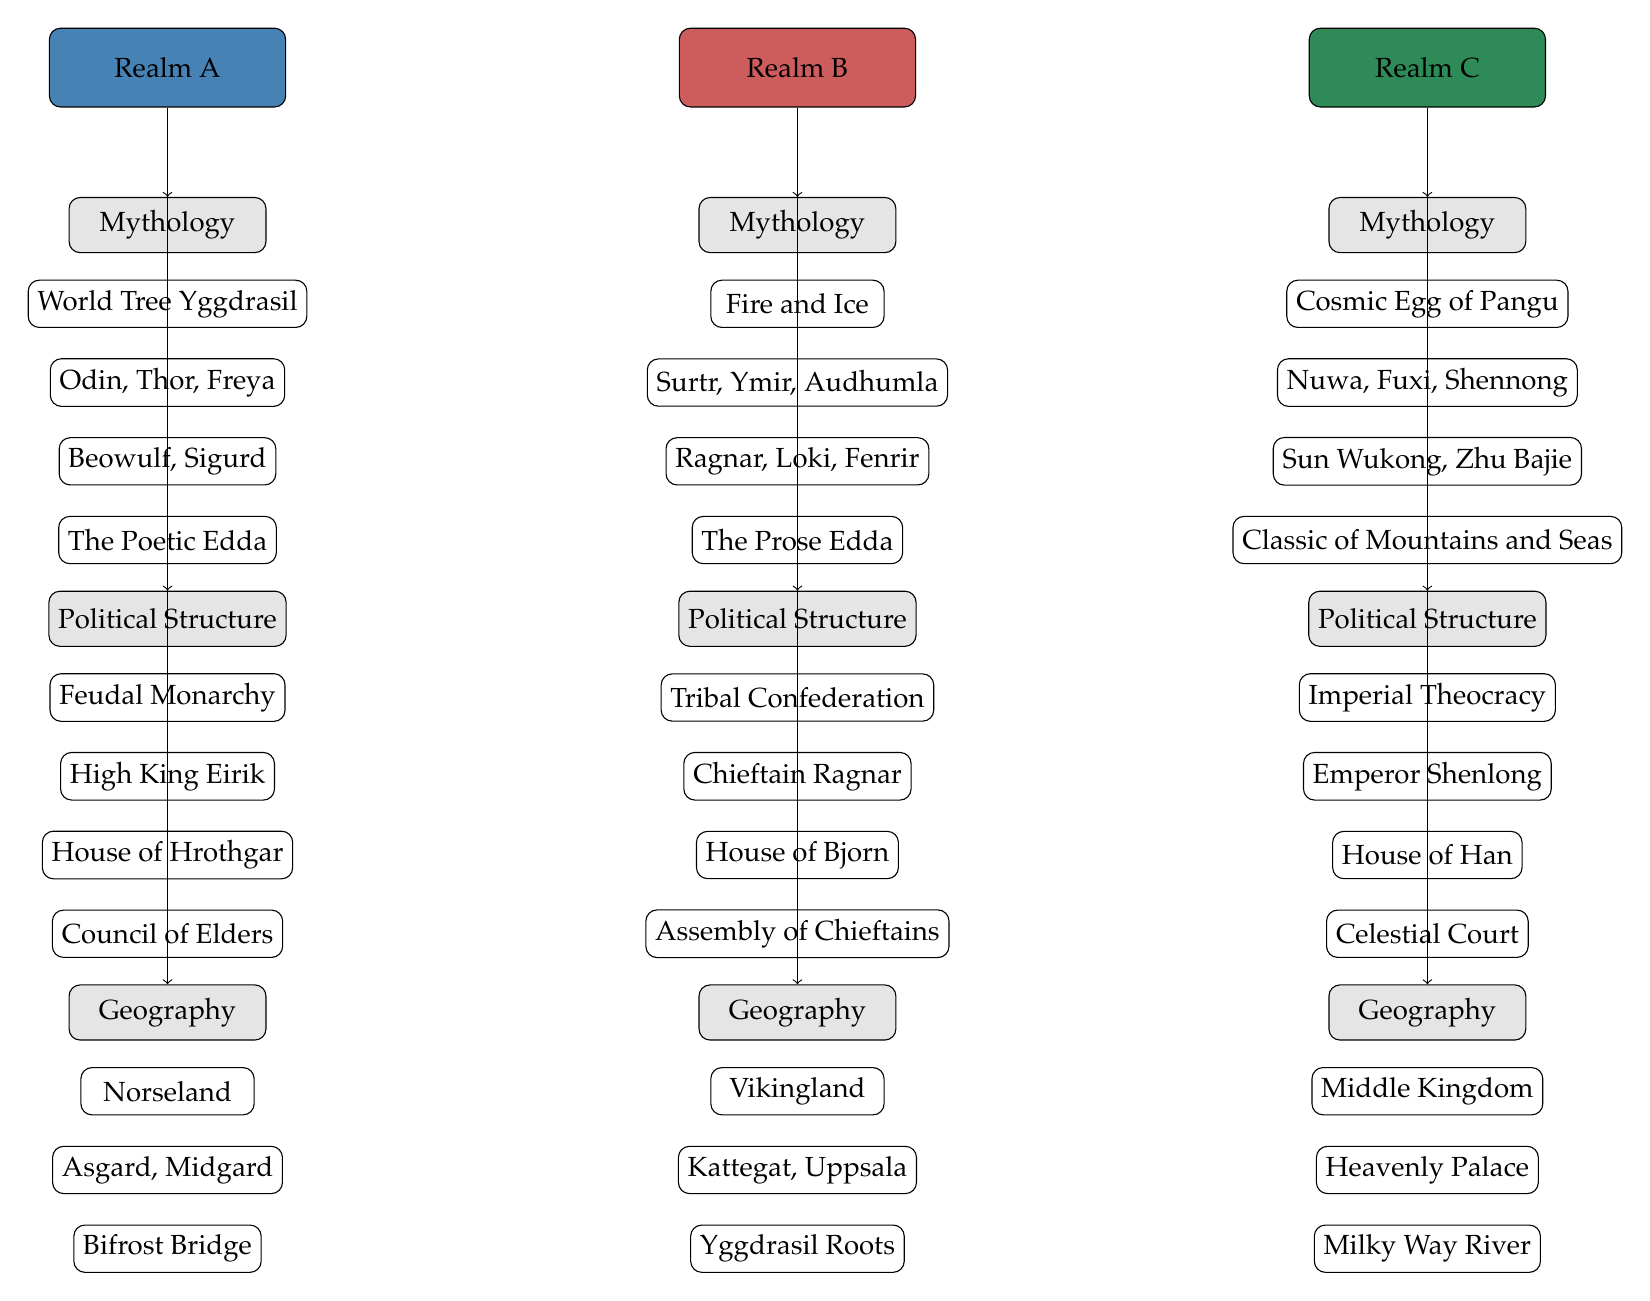What is the primary political structure in Realm A? Realm A's primary political structure is labeled directly under "Political Structure," which states "Feudal Monarchy."
Answer: Feudal Monarchy Which deity is associated with Realm C? The deities associated with Realm C are listed under its "Mythology" category, specifically mentioning "Nuwa, Fuxi, Shennong."
Answer: Nuwa, Fuxi, Shennong How many distinct realms are depicted in this diagram? The diagram presents three distinct realms, namely Realm A, Realm B, and Realm C, as identified at the top of the diagram.
Answer: 3 What significant geographical feature is found in Realm A? Under the "Geography" section for Realm A, the feature listed is "Bifrost Bridge," indicating its significance in this fantasy realm.
Answer: Bifrost Bridge Who rules in Realm B? The ruler of Realm B is identified under the "Political Structure" section, listed as "Chieftain Ragnar."
Answer: Chieftain Ragnar What is the common theme among all realms in the "Mythology" category? Each realm's mythology includes a unique creation myth, showing a variety of foundational stories: Yggdrasil for Realm A, Fire and Ice for Realm B, and the Cosmic Egg for Realm C. The commonality is the emphasis on these foundational narratives.
Answer: Creation myths Which council exists in Realm C? Realm C's political structure includes a council labeled as the "Celestial Court," which is specified under the "Political Structure" category for that realm.
Answer: Celestial Court What is the document related to the mythology of Realm B? Under Realm B's mythology, the related document is given as "The Prose Edda," which is classified in the "Mythology" section of the diagram.
Answer: The Prose Edda Which locations are cited in Realm B’s geography? The locations noted under Realm B's "Geography" category include "Kattegat, Uppsala," indicating key places within this realm's setting.
Answer: Kattegat, Uppsala 